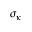Convert formula to latex. <formula><loc_0><loc_0><loc_500><loc_500>\sigma _ { \kappa }</formula> 